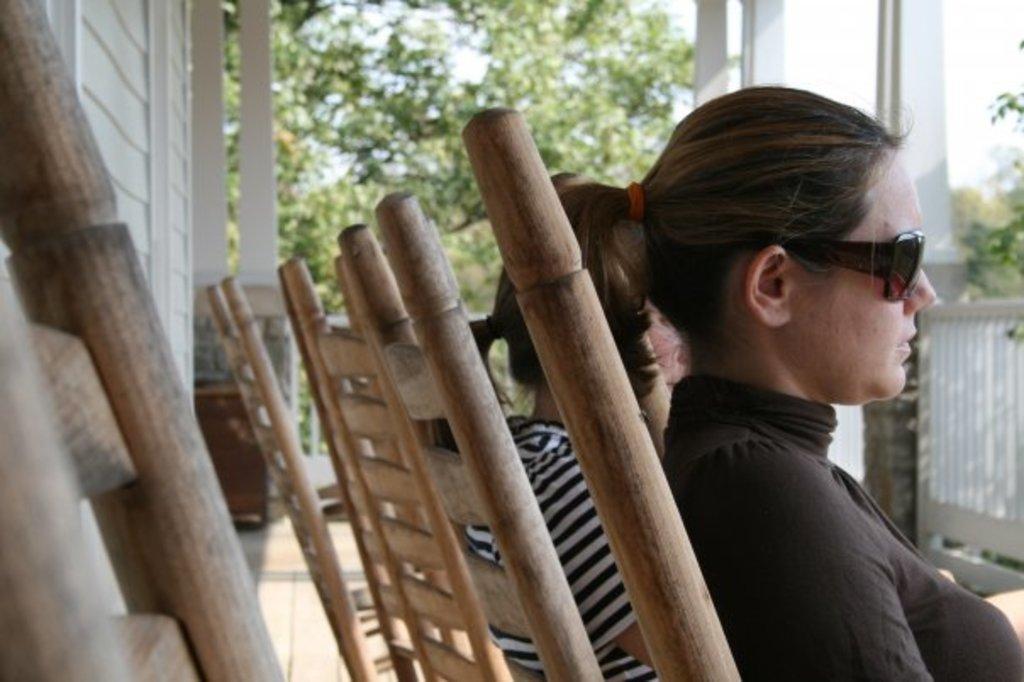How would you summarize this image in a sentence or two? In this image we can see women sitting on the chairs. On the left side of the image there is a wall. In the background there are trees and sky. 